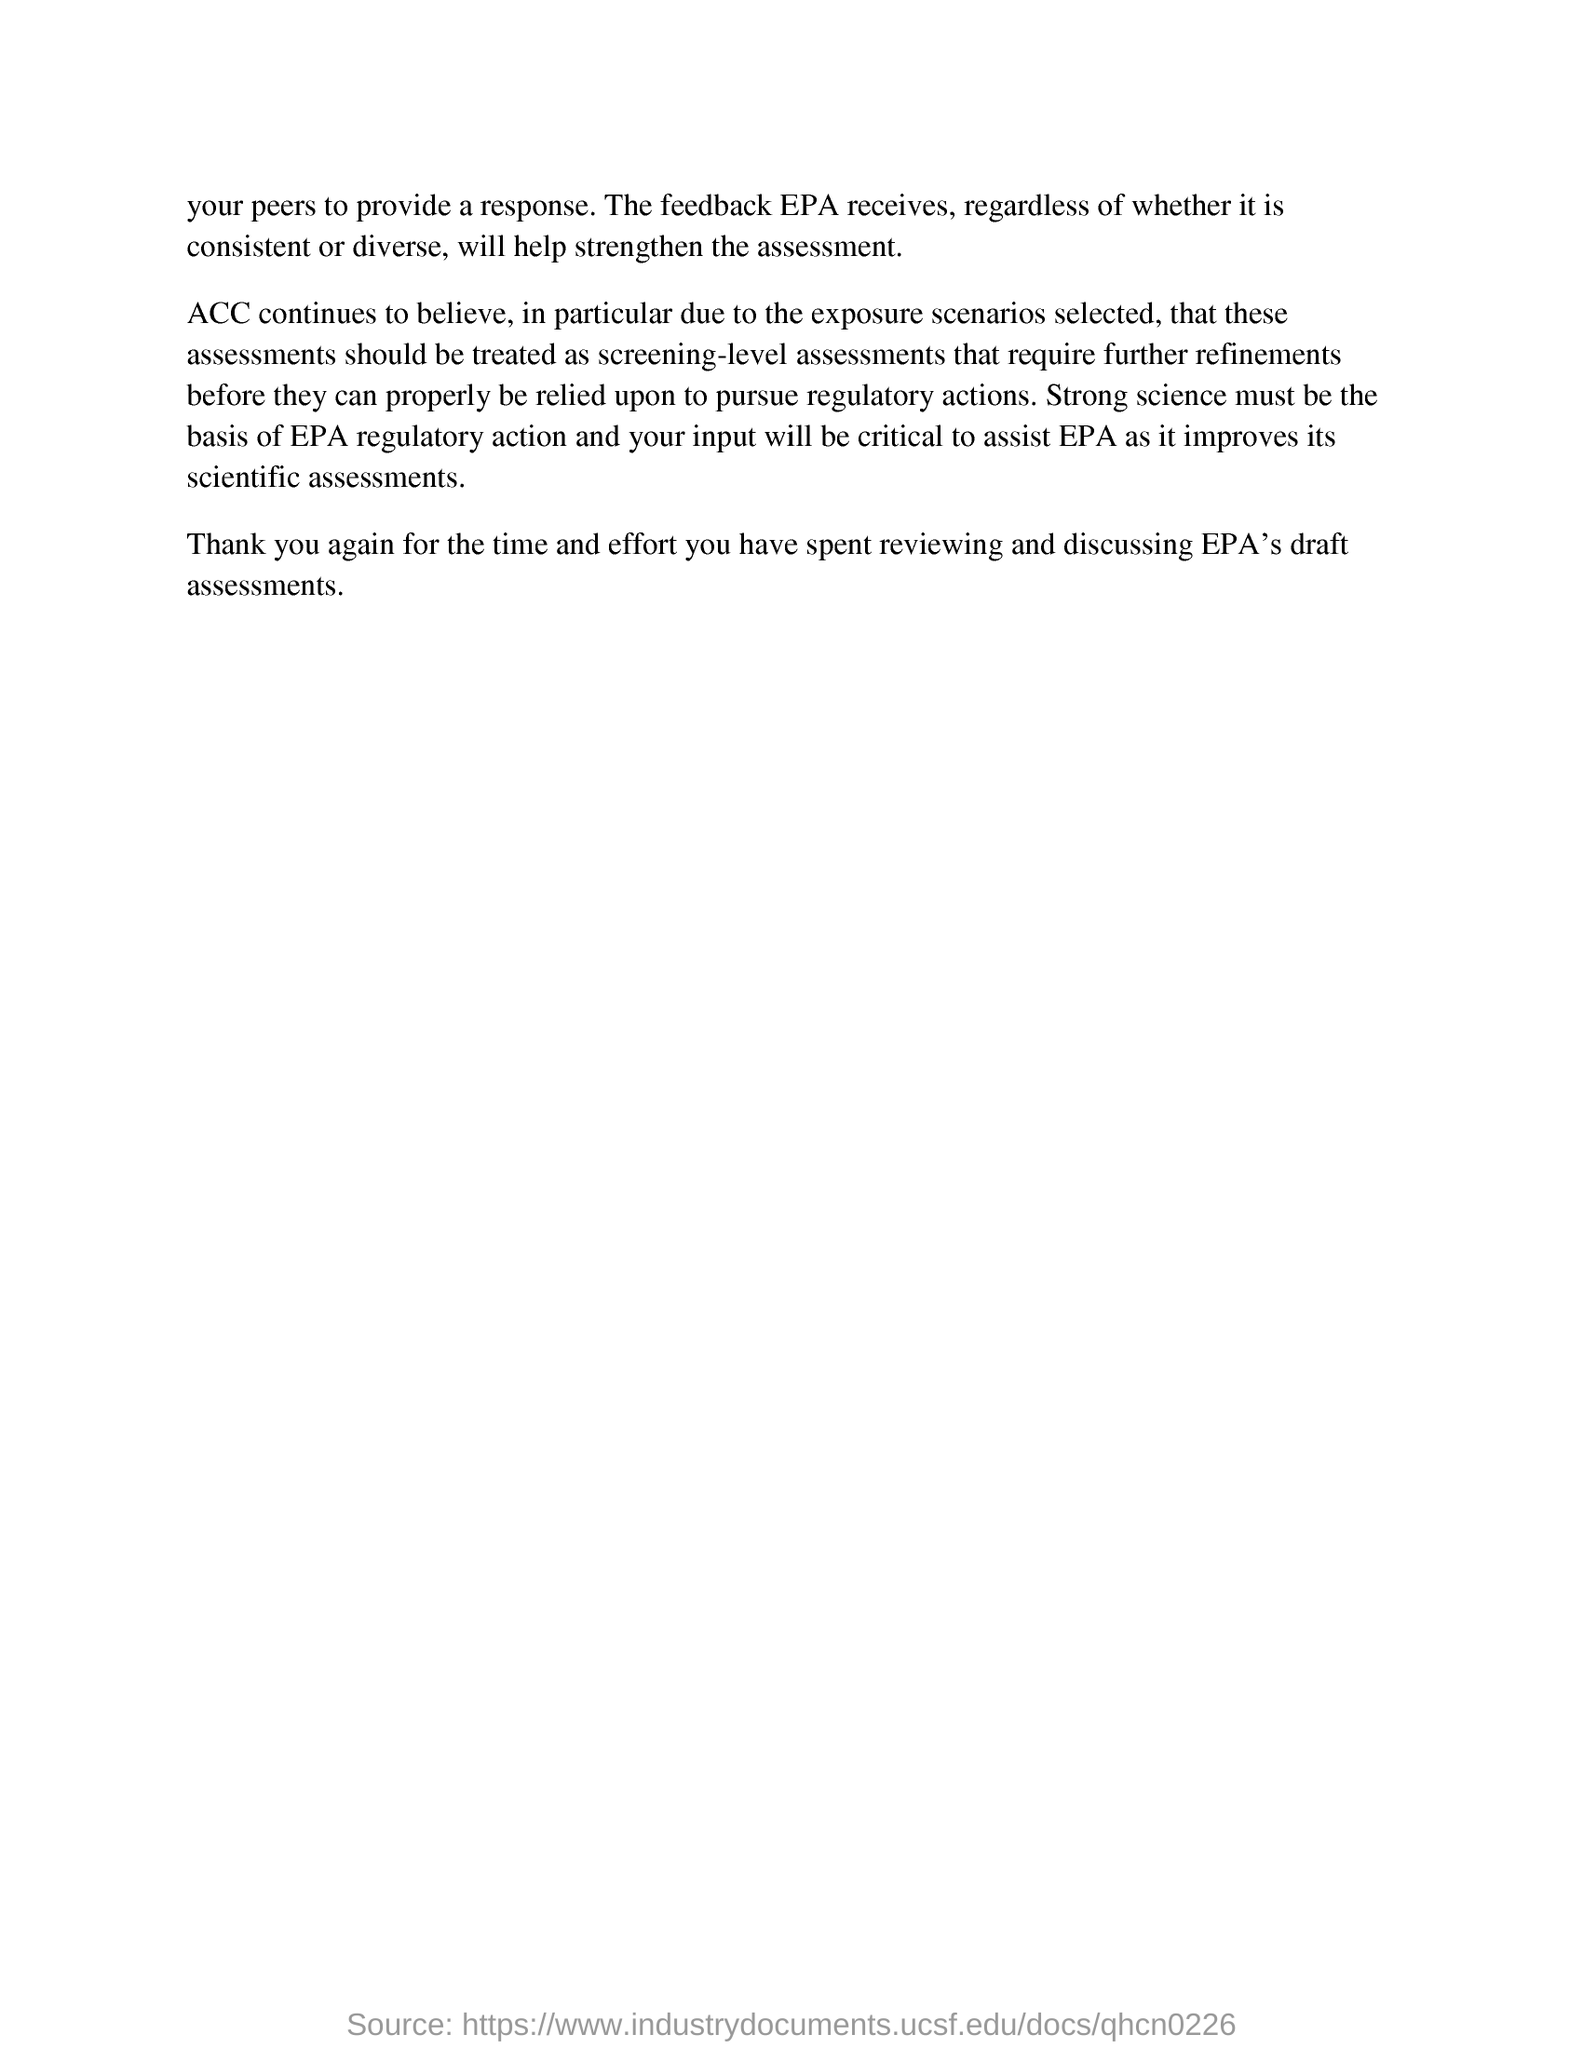What should be the basis of EPA regulatory action?
Your answer should be very brief. Strong science. 